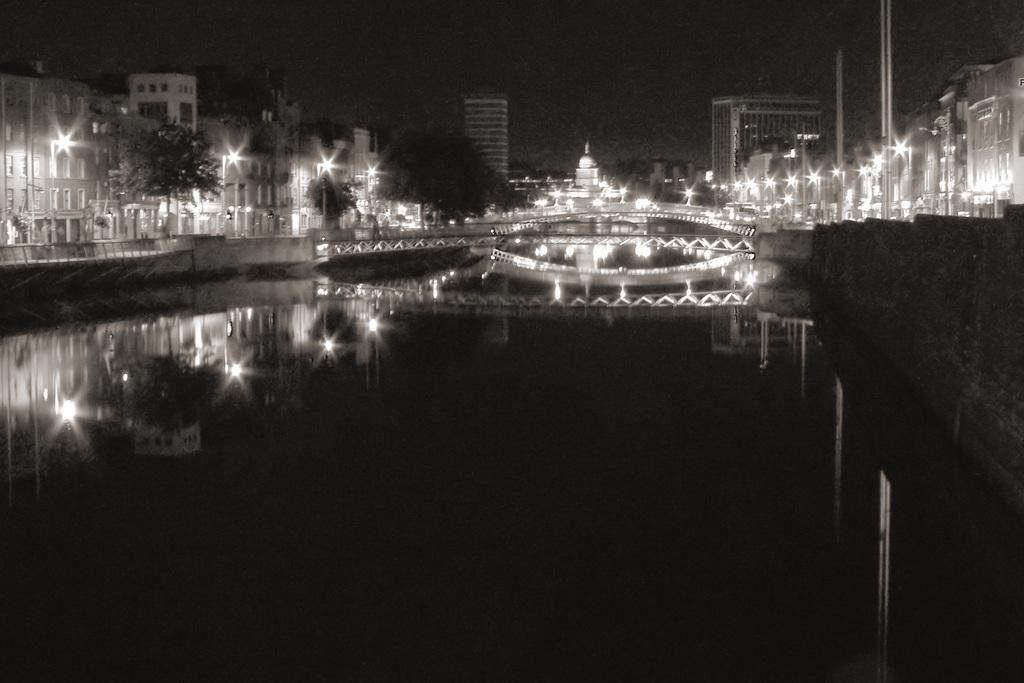What type of landscape is depicted in the image? The image shows a city near water. What connects the two sides of the water in the image? There is a bridge in the image. What structures can be seen in the city? There are buildings in the image. What provides illumination at night in the image? Street lights are visible in the image. What objects are present along the bridge or streets in the image? There are poles in the image. What type of twig is being used as a toy by the fruit in the image? There is no twig, toy, or fruit present in the image. 